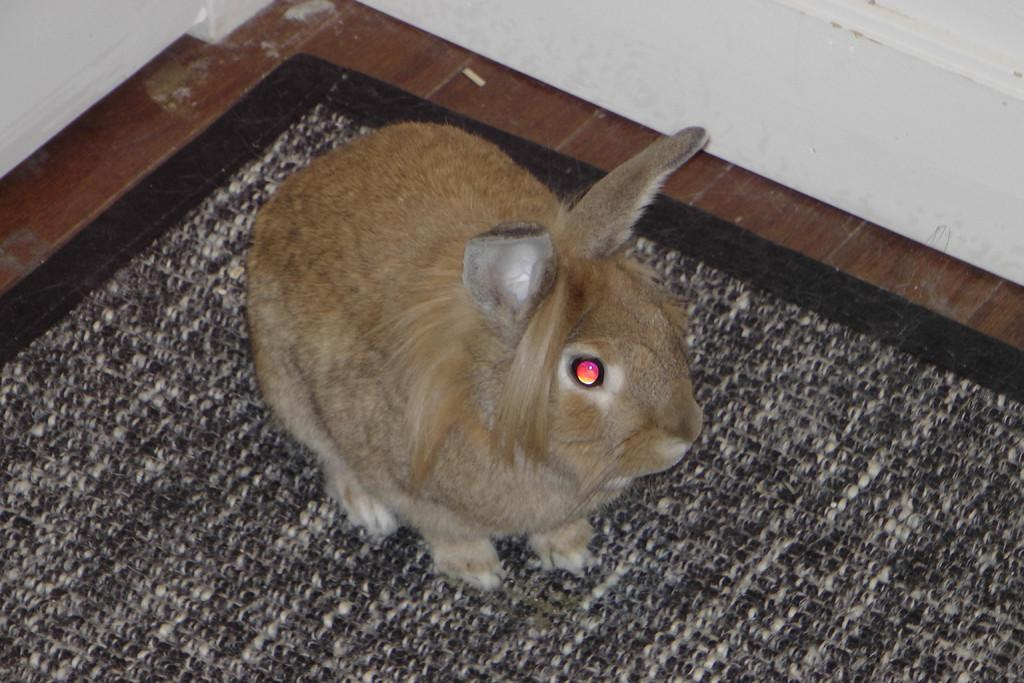What animal is present in the image? There is a rabbit in the image. What is the rabbit standing on? The rabbit is standing on a mat. What can be seen in the background of the image? There is a wall in the background of the image. What type of slope can be seen in the image? There is no slope present in the image; it features a rabbit standing on a mat with a wall in the background. 